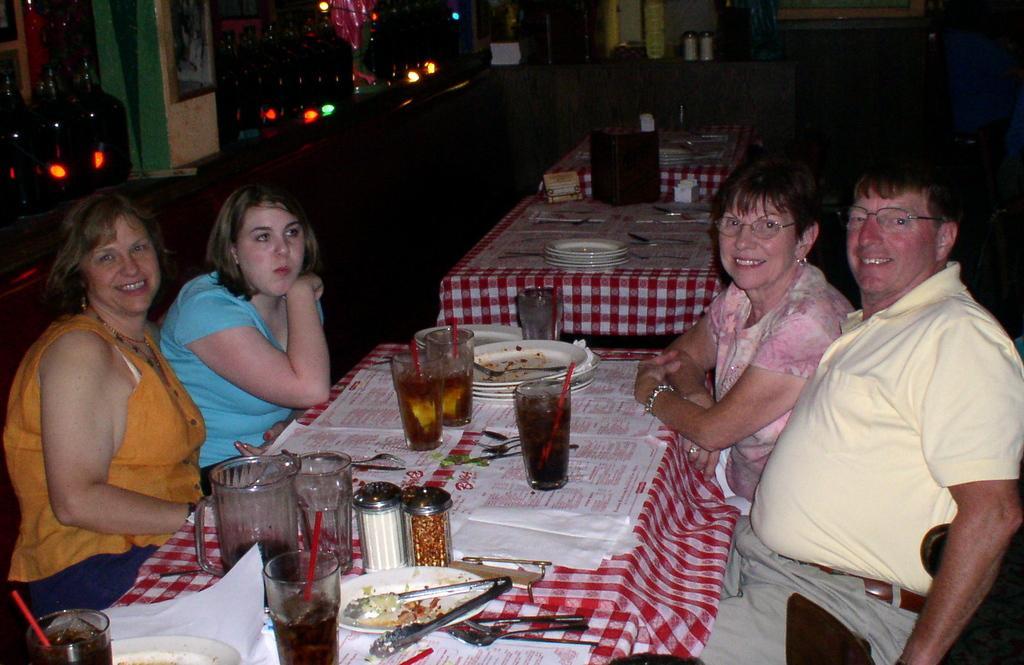How would you summarize this image in a sentence or two? In this image I can see four people sitting in-front of the table. On the table I can see the plates and glasses. I can also see the forks and spoons. These people are wearing the different color dresses. To the side I can see few more tables. In the back there are lights. 